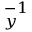Convert formula to latex. <formula><loc_0><loc_0><loc_500><loc_500>_ { y } ^ { - 1 }</formula> 